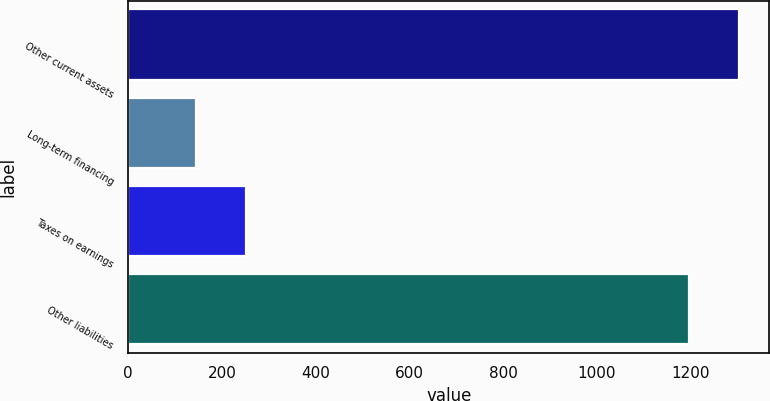Convert chart to OTSL. <chart><loc_0><loc_0><loc_500><loc_500><bar_chart><fcel>Other current assets<fcel>Long-term financing<fcel>Taxes on earnings<fcel>Other liabilities<nl><fcel>1302.4<fcel>145<fcel>251.4<fcel>1196<nl></chart> 